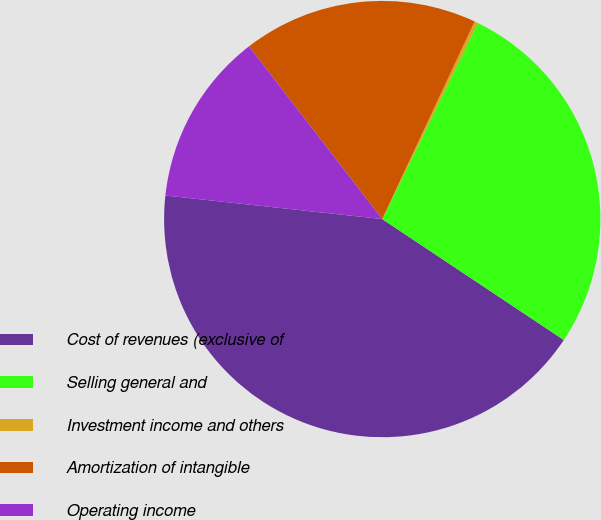Convert chart to OTSL. <chart><loc_0><loc_0><loc_500><loc_500><pie_chart><fcel>Cost of revenues (exclusive of<fcel>Selling general and<fcel>Investment income and others<fcel>Amortization of intangible<fcel>Operating income<nl><fcel>42.37%<fcel>27.13%<fcel>0.26%<fcel>17.42%<fcel>12.82%<nl></chart> 